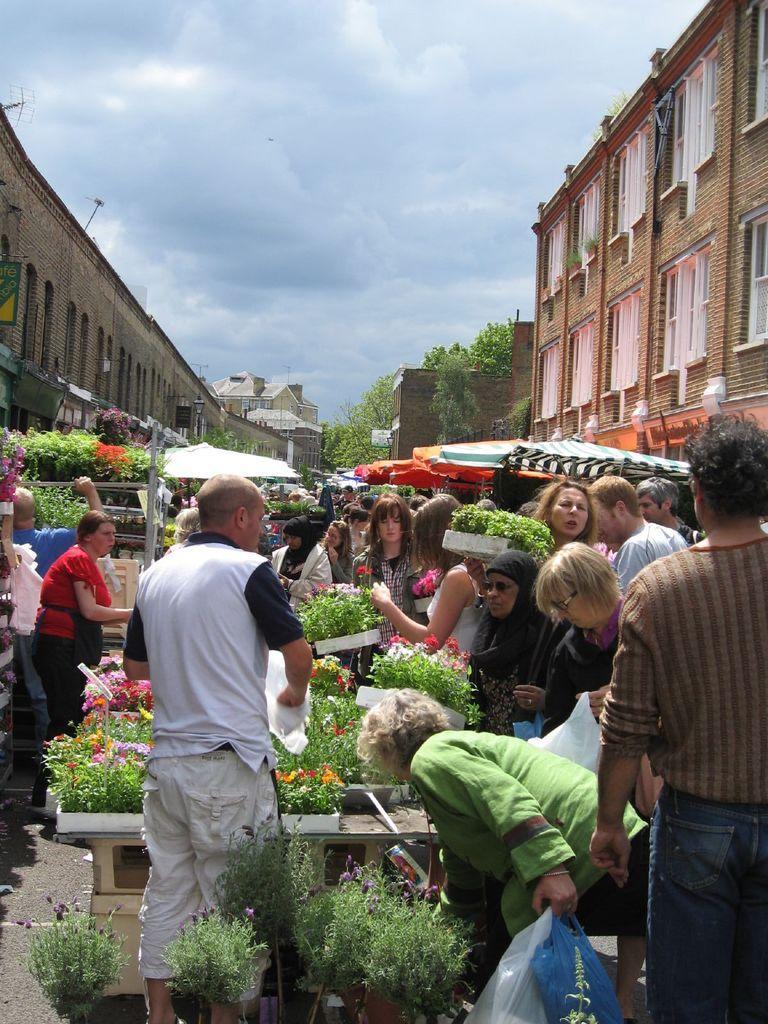Can you describe this image briefly? In this picture we can see some men and women standing in the open market and purchasing the green plant. In the front there is a man wearing a white t-shirt and standing. On both sides we can see buildings. On the top there is a sky and clouds. 